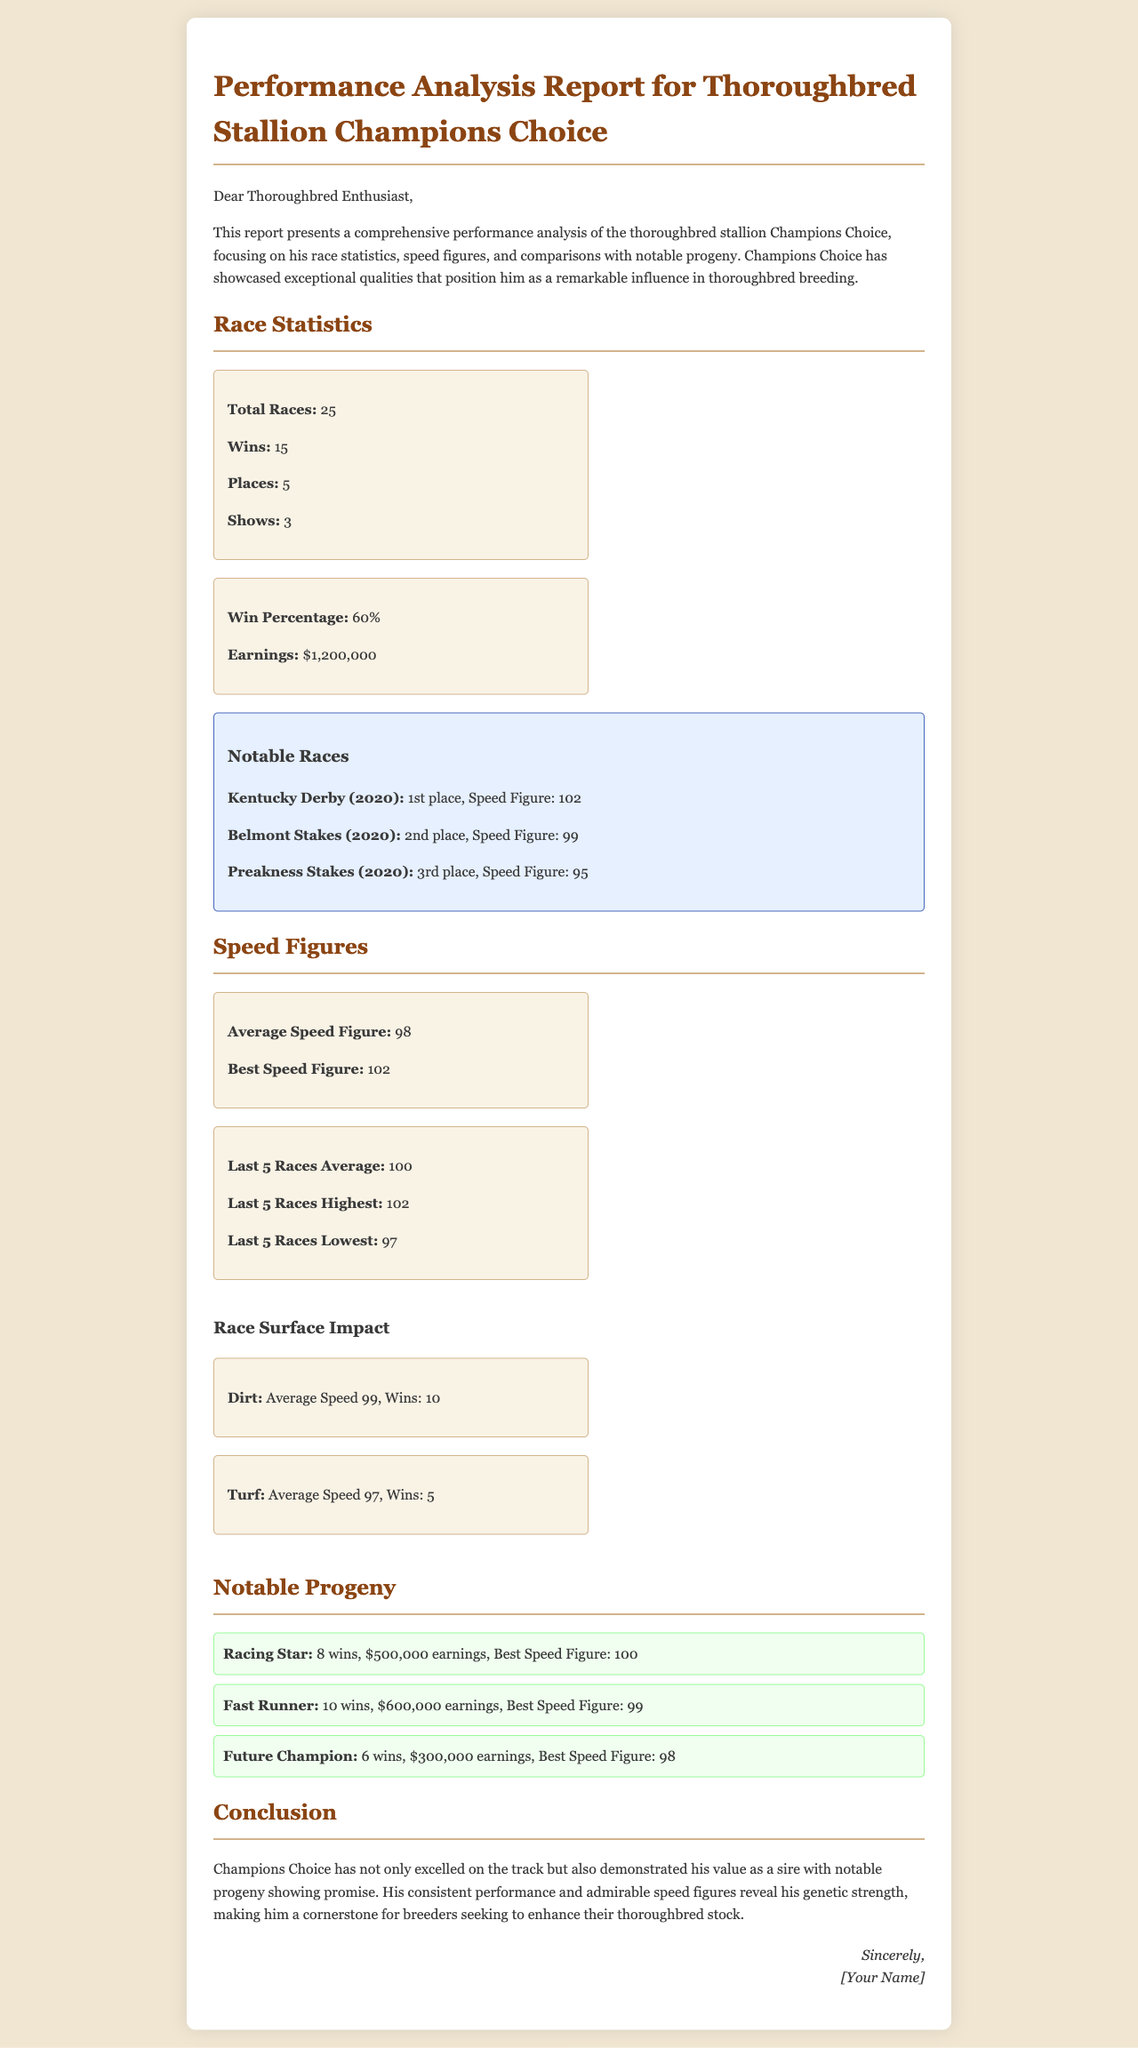What is the total number of races Champions Choice participated in? The total number of races is explicitly stated in the race statistics section of the document as 25.
Answer: 25 What percentage of races did Champions Choice win? The win percentage is provided in the race statistics section, which shows a win percentage of 60%.
Answer: 60% How many notable progeny does Champions Choice have listed? The document lists three notable progeny, which can be counted from the progeny section.
Answer: 3 What was Champions Choice's best speed figure? The best speed figure is mentioned under the speed figures section, recorded as 102.
Answer: 102 What was the average speed figure for Champions Choice in his last five races? The average speed figure of the last five races is provided in the speed figures section as 100.
Answer: 100 Which race did Champions Choice finish in 1st place? The report mentions that Champions Choice finished 1st in the Kentucky Derby in 2020.
Answer: Kentucky Derby What were Champions Choice's earnings throughout his racing career? The total earnings mentioned in the document are $1,200,000, found in the race statistics section.
Answer: $1,200,000 What was Champions Choice's average speed on dirt? The document shows that the average speed on dirt was 99, as specified in the race surface impact section.
Answer: 99 What is the name of one notable progeny of Champions Choice? One of the notable progeny mentioned is Racing Star, listed in the progeny section of the document.
Answer: Racing Star 